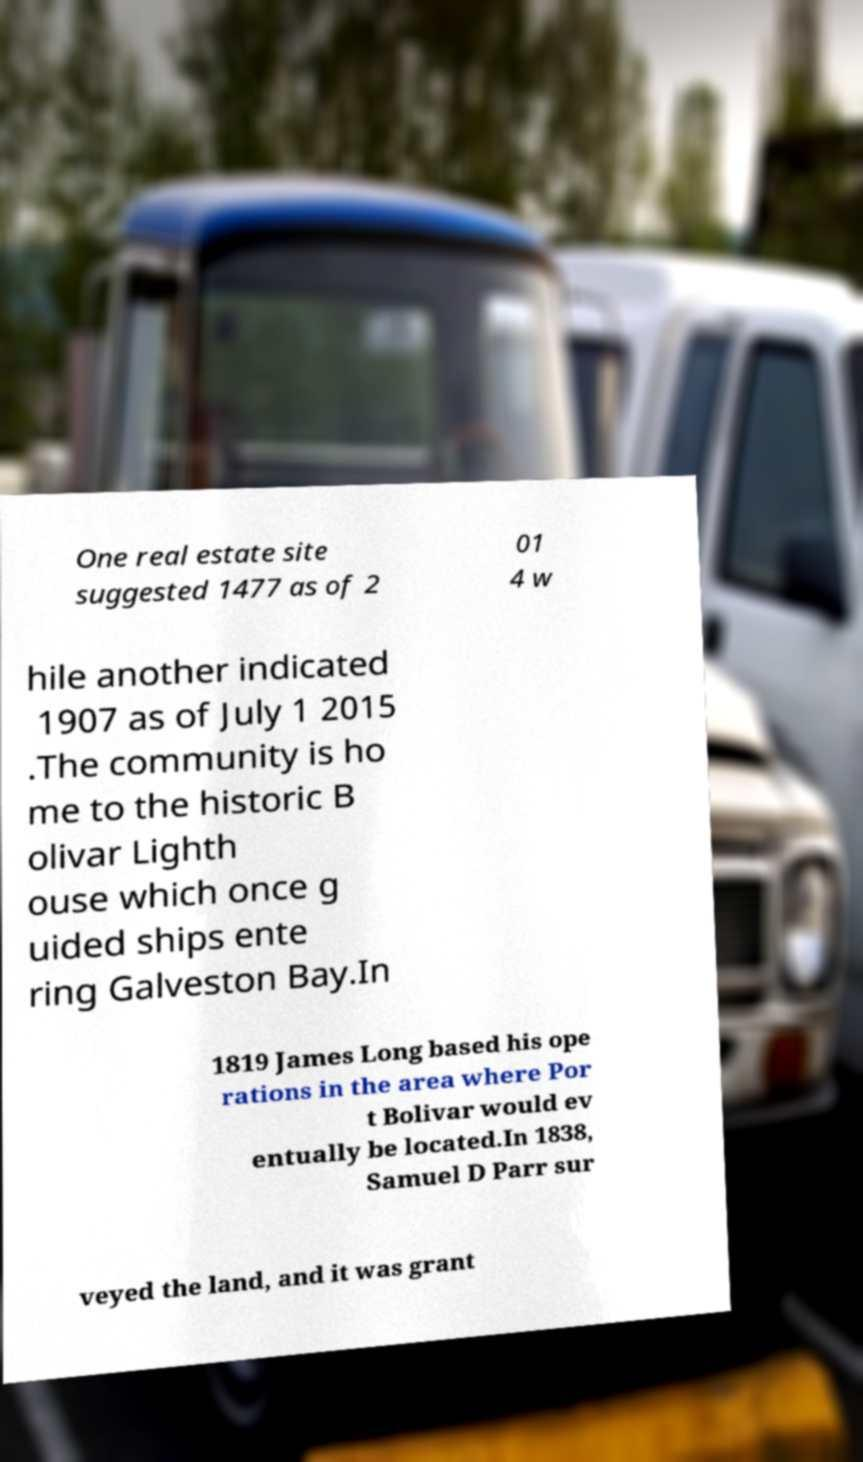I need the written content from this picture converted into text. Can you do that? One real estate site suggested 1477 as of 2 01 4 w hile another indicated 1907 as of July 1 2015 .The community is ho me to the historic B olivar Lighth ouse which once g uided ships ente ring Galveston Bay.In 1819 James Long based his ope rations in the area where Por t Bolivar would ev entually be located.In 1838, Samuel D Parr sur veyed the land, and it was grant 